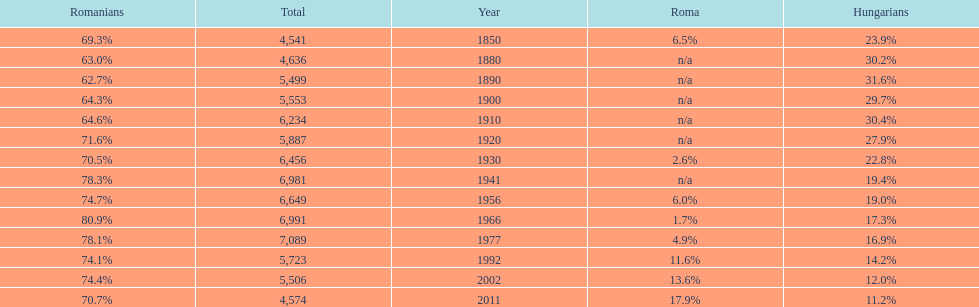What year had the highest total number? 1977. 